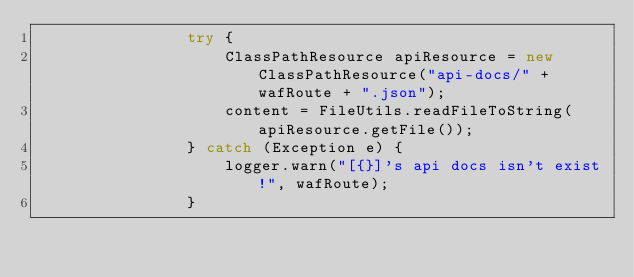<code> <loc_0><loc_0><loc_500><loc_500><_Java_>                try {
                    ClassPathResource apiResource = new ClassPathResource("api-docs/" + wafRoute + ".json");
                    content = FileUtils.readFileToString(apiResource.getFile());
                } catch (Exception e) {
                    logger.warn("[{}]'s api docs isn't exist!", wafRoute);
                }</code> 